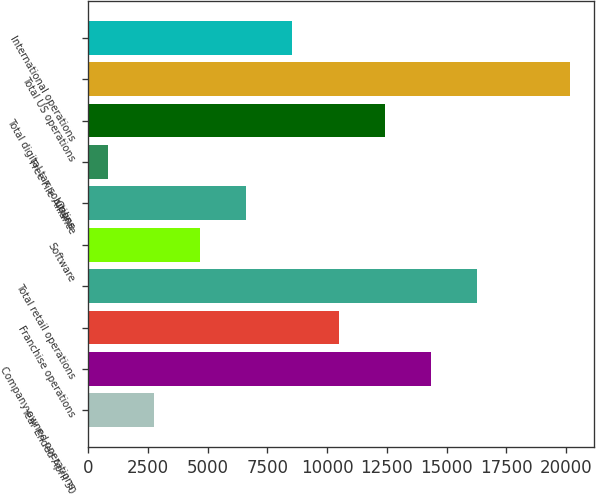Convert chart to OTSL. <chart><loc_0><loc_0><loc_500><loc_500><bar_chart><fcel>Year Ended April 30<fcel>Company-owned operations<fcel>Franchise operations<fcel>Total retail operations<fcel>Software<fcel>Online<fcel>Free File Alliance<fcel>Total digital tax solutions<fcel>Total US operations<fcel>International operations<nl><fcel>2743.2<fcel>14342.4<fcel>10476<fcel>16275.6<fcel>4676.4<fcel>6609.6<fcel>810<fcel>12409.2<fcel>20142<fcel>8542.8<nl></chart> 